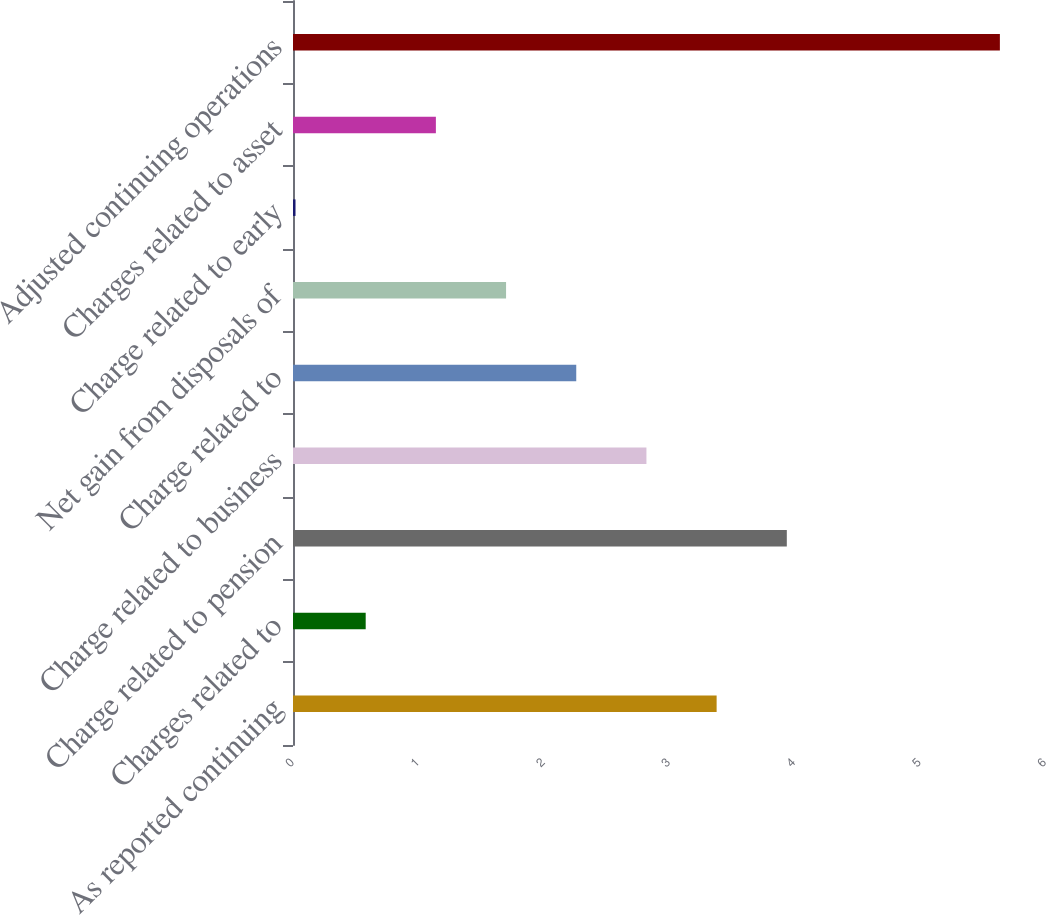Convert chart to OTSL. <chart><loc_0><loc_0><loc_500><loc_500><bar_chart><fcel>As reported continuing<fcel>Charges related to<fcel>Charge related to pension<fcel>Charge related to business<fcel>Charge related to<fcel>Net gain from disposals of<fcel>Charge related to early<fcel>Charges related to asset<fcel>Adjusted continuing operations<nl><fcel>3.38<fcel>0.58<fcel>3.94<fcel>2.82<fcel>2.26<fcel>1.7<fcel>0.02<fcel>1.14<fcel>5.64<nl></chart> 